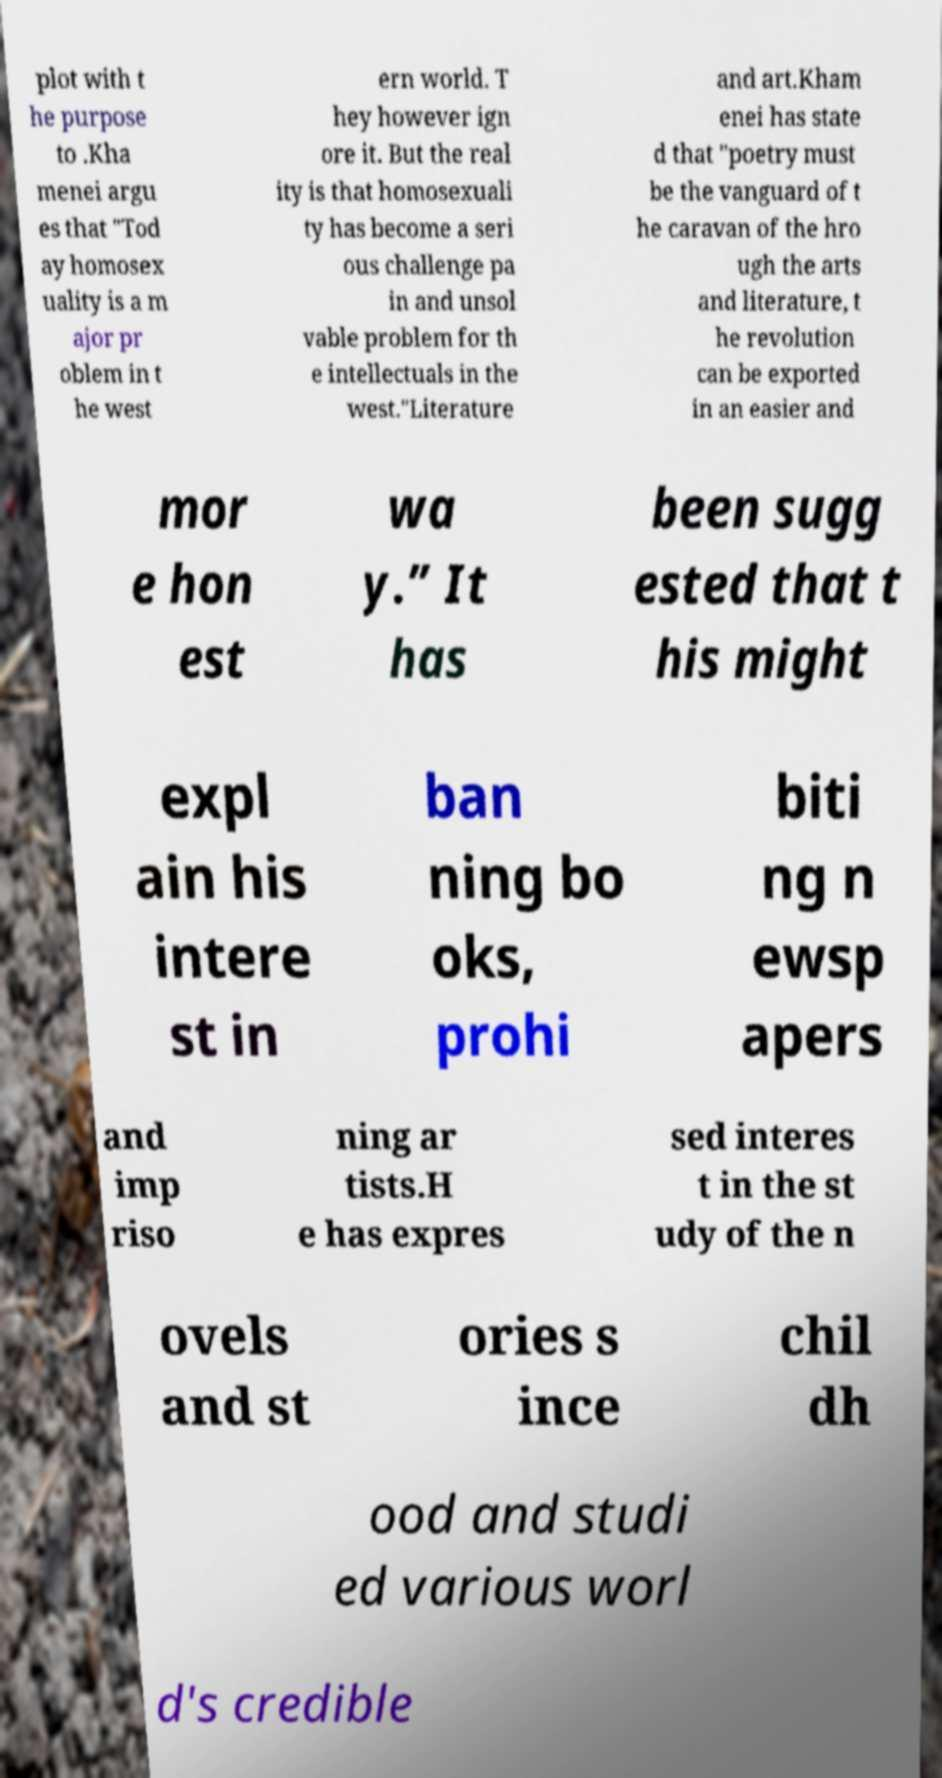For documentation purposes, I need the text within this image transcribed. Could you provide that? plot with t he purpose to .Kha menei argu es that "Tod ay homosex uality is a m ajor pr oblem in t he west ern world. T hey however ign ore it. But the real ity is that homosexuali ty has become a seri ous challenge pa in and unsol vable problem for th e intellectuals in the west."Literature and art.Kham enei has state d that "poetry must be the vanguard of t he caravan of the hro ugh the arts and literature, t he revolution can be exported in an easier and mor e hon est wa y.” It has been sugg ested that t his might expl ain his intere st in ban ning bo oks, prohi biti ng n ewsp apers and imp riso ning ar tists.H e has expres sed interes t in the st udy of the n ovels and st ories s ince chil dh ood and studi ed various worl d's credible 